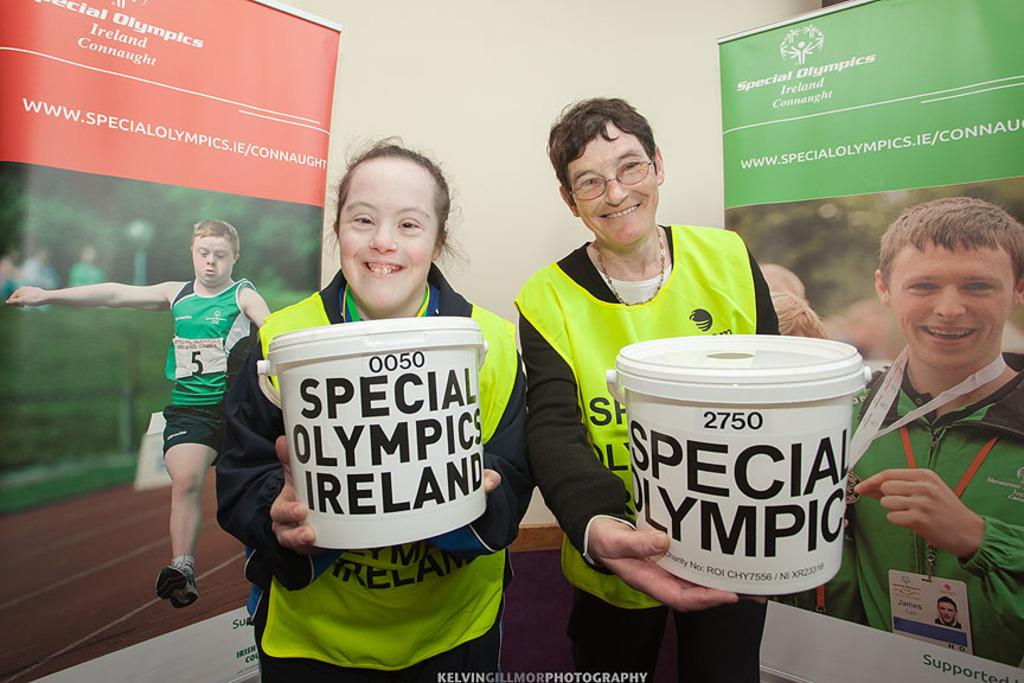How many people are present in the image? There are two people in the image. What are the people holding in their hands? The people are holding white objects. What can be seen in the background of the image? There are banners visible in the background, and the sky is also visible. Is there a volcano erupting in the background of the image? No, there is no volcano present in the image. What type of bread can be seen in the hands of the people? There is no bread visible in the image; the people are holding white objects, but their nature is not specified. 